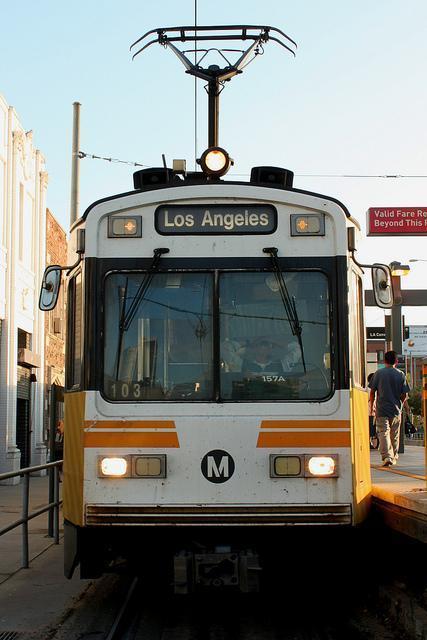How many people are there?
Give a very brief answer. 2. 